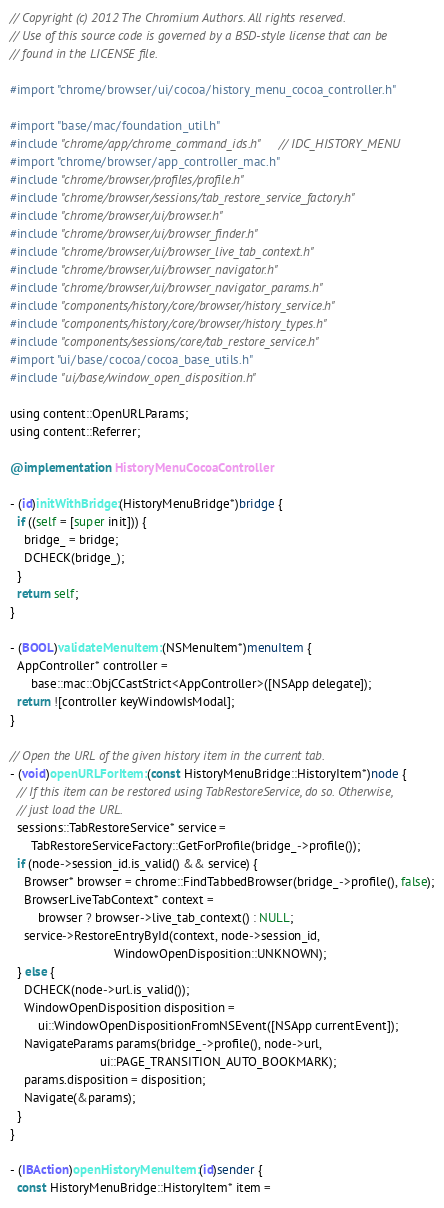<code> <loc_0><loc_0><loc_500><loc_500><_ObjectiveC_>// Copyright (c) 2012 The Chromium Authors. All rights reserved.
// Use of this source code is governed by a BSD-style license that can be
// found in the LICENSE file.

#import "chrome/browser/ui/cocoa/history_menu_cocoa_controller.h"

#import "base/mac/foundation_util.h"
#include "chrome/app/chrome_command_ids.h"  // IDC_HISTORY_MENU
#import "chrome/browser/app_controller_mac.h"
#include "chrome/browser/profiles/profile.h"
#include "chrome/browser/sessions/tab_restore_service_factory.h"
#include "chrome/browser/ui/browser.h"
#include "chrome/browser/ui/browser_finder.h"
#include "chrome/browser/ui/browser_live_tab_context.h"
#include "chrome/browser/ui/browser_navigator.h"
#include "chrome/browser/ui/browser_navigator_params.h"
#include "components/history/core/browser/history_service.h"
#include "components/history/core/browser/history_types.h"
#include "components/sessions/core/tab_restore_service.h"
#import "ui/base/cocoa/cocoa_base_utils.h"
#include "ui/base/window_open_disposition.h"

using content::OpenURLParams;
using content::Referrer;

@implementation HistoryMenuCocoaController

- (id)initWithBridge:(HistoryMenuBridge*)bridge {
  if ((self = [super init])) {
    bridge_ = bridge;
    DCHECK(bridge_);
  }
  return self;
}

- (BOOL)validateMenuItem:(NSMenuItem*)menuItem {
  AppController* controller =
      base::mac::ObjCCastStrict<AppController>([NSApp delegate]);
  return ![controller keyWindowIsModal];
}

// Open the URL of the given history item in the current tab.
- (void)openURLForItem:(const HistoryMenuBridge::HistoryItem*)node {
  // If this item can be restored using TabRestoreService, do so. Otherwise,
  // just load the URL.
  sessions::TabRestoreService* service =
      TabRestoreServiceFactory::GetForProfile(bridge_->profile());
  if (node->session_id.is_valid() && service) {
    Browser* browser = chrome::FindTabbedBrowser(bridge_->profile(), false);
    BrowserLiveTabContext* context =
        browser ? browser->live_tab_context() : NULL;
    service->RestoreEntryById(context, node->session_id,
                              WindowOpenDisposition::UNKNOWN);
  } else {
    DCHECK(node->url.is_valid());
    WindowOpenDisposition disposition =
        ui::WindowOpenDispositionFromNSEvent([NSApp currentEvent]);
    NavigateParams params(bridge_->profile(), node->url,
                          ui::PAGE_TRANSITION_AUTO_BOOKMARK);
    params.disposition = disposition;
    Navigate(&params);
  }
}

- (IBAction)openHistoryMenuItem:(id)sender {
  const HistoryMenuBridge::HistoryItem* item =</code> 